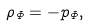Convert formula to latex. <formula><loc_0><loc_0><loc_500><loc_500>\rho _ { \Phi } = - p _ { \Phi } ,</formula> 